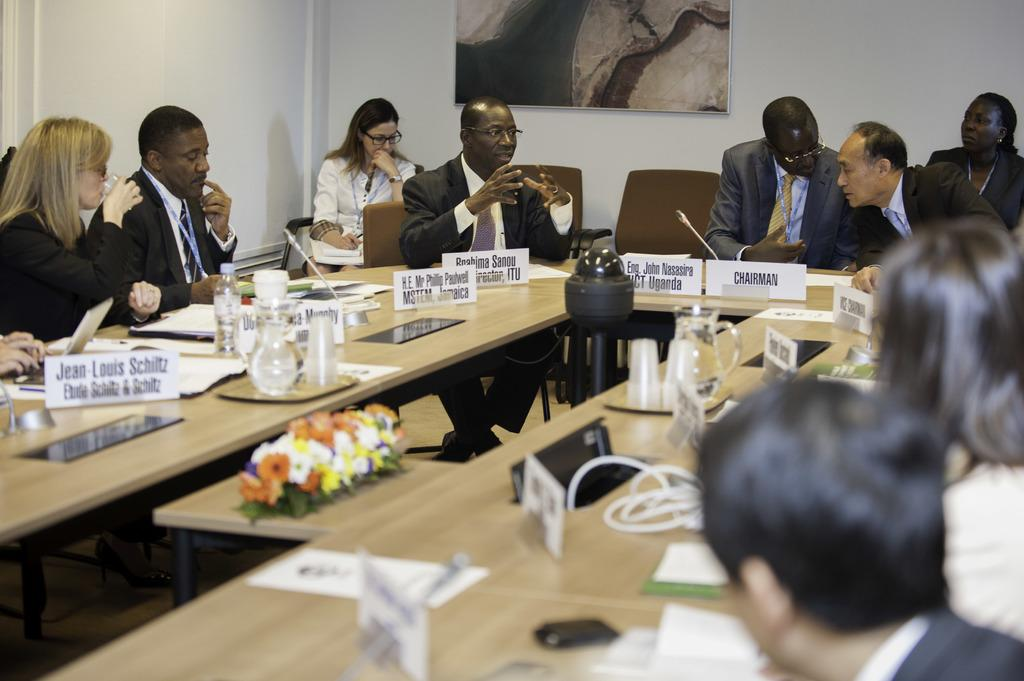How many people are in the image? There is a group of people in the image. Where are the people located in the image? The people are sitting in a meeting room. What are the people doing in the image? The people are having a discussion. What type of jewel can be seen on the table in the image? There is no jewel present in the image; it features a group of people sitting in a meeting room and having a discussion. 